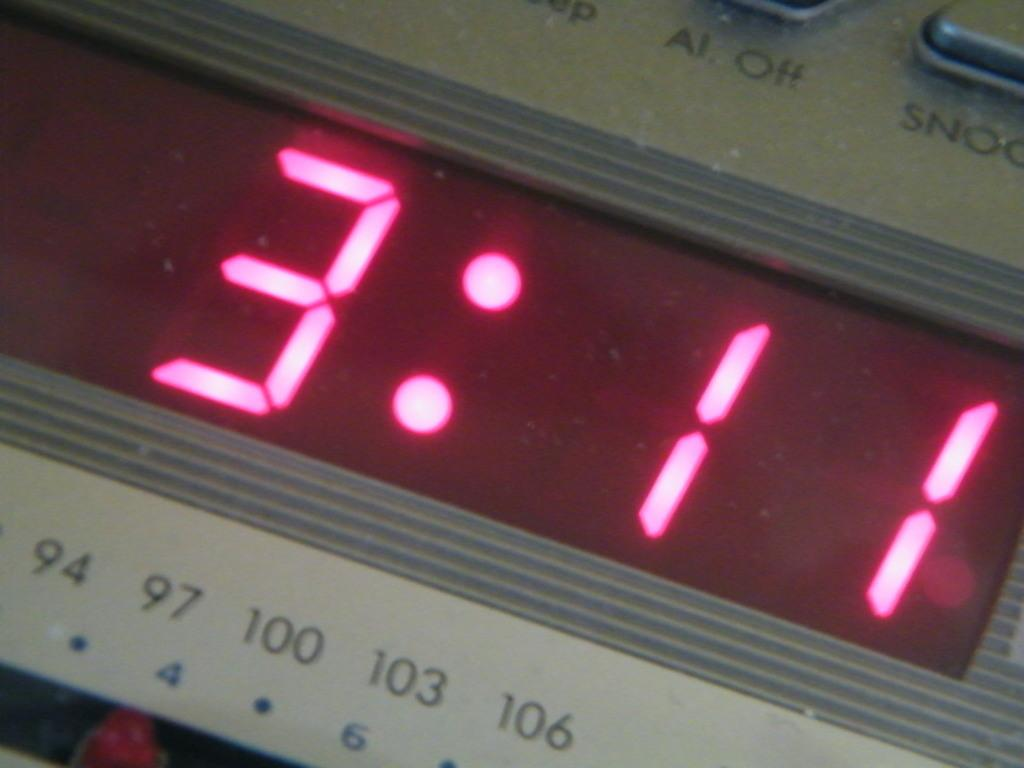<image>
Write a terse but informative summary of the picture. Digital alarm clock displaying 3:11 in red lights. 